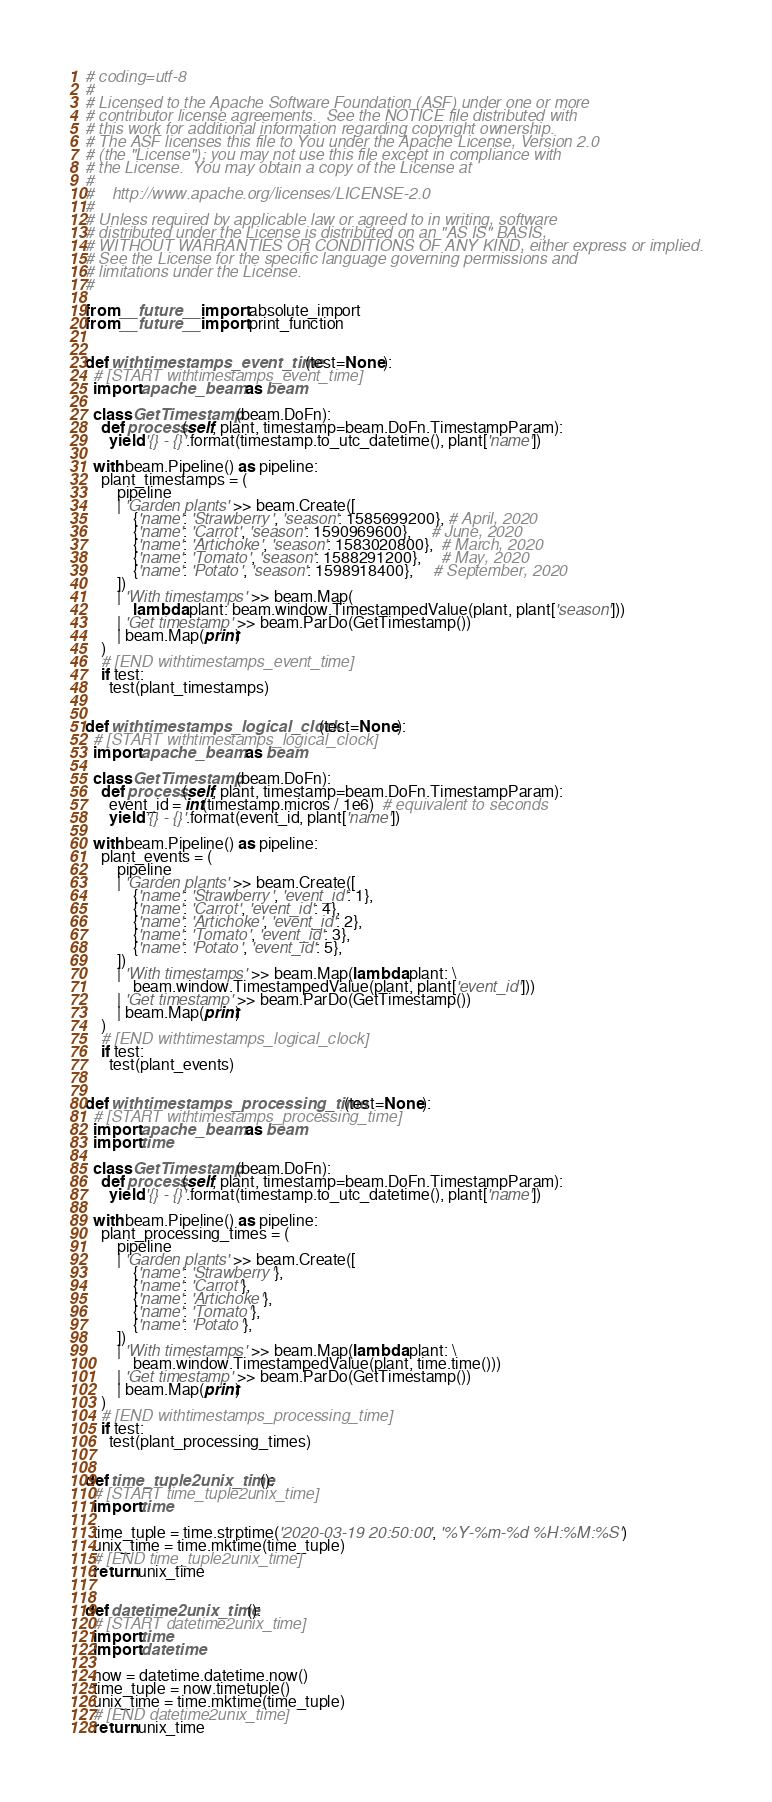Convert code to text. <code><loc_0><loc_0><loc_500><loc_500><_Python_># coding=utf-8
#
# Licensed to the Apache Software Foundation (ASF) under one or more
# contributor license agreements.  See the NOTICE file distributed with
# this work for additional information regarding copyright ownership.
# The ASF licenses this file to You under the Apache License, Version 2.0
# (the "License"); you may not use this file except in compliance with
# the License.  You may obtain a copy of the License at
#
#    http://www.apache.org/licenses/LICENSE-2.0
#
# Unless required by applicable law or agreed to in writing, software
# distributed under the License is distributed on an "AS IS" BASIS,
# WITHOUT WARRANTIES OR CONDITIONS OF ANY KIND, either express or implied.
# See the License for the specific language governing permissions and
# limitations under the License.
#

from __future__ import absolute_import
from __future__ import print_function


def withtimestamps_event_time(test=None):
  # [START withtimestamps_event_time]
  import apache_beam as beam

  class GetTimestamp(beam.DoFn):
    def process(self, plant, timestamp=beam.DoFn.TimestampParam):
      yield '{} - {}'.format(timestamp.to_utc_datetime(), plant['name'])

  with beam.Pipeline() as pipeline:
    plant_timestamps = (
        pipeline
        | 'Garden plants' >> beam.Create([
            {'name': 'Strawberry', 'season': 1585699200}, # April, 2020
            {'name': 'Carrot', 'season': 1590969600},     # June, 2020
            {'name': 'Artichoke', 'season': 1583020800},  # March, 2020
            {'name': 'Tomato', 'season': 1588291200},     # May, 2020
            {'name': 'Potato', 'season': 1598918400},     # September, 2020
        ])
        | 'With timestamps' >> beam.Map(
            lambda plant: beam.window.TimestampedValue(plant, plant['season']))
        | 'Get timestamp' >> beam.ParDo(GetTimestamp())
        | beam.Map(print)
    )
    # [END withtimestamps_event_time]
    if test:
      test(plant_timestamps)


def withtimestamps_logical_clock(test=None):
  # [START withtimestamps_logical_clock]
  import apache_beam as beam

  class GetTimestamp(beam.DoFn):
    def process(self, plant, timestamp=beam.DoFn.TimestampParam):
      event_id = int(timestamp.micros / 1e6)  # equivalent to seconds
      yield '{} - {}'.format(event_id, plant['name'])

  with beam.Pipeline() as pipeline:
    plant_events = (
        pipeline
        | 'Garden plants' >> beam.Create([
            {'name': 'Strawberry', 'event_id': 1},
            {'name': 'Carrot', 'event_id': 4},
            {'name': 'Artichoke', 'event_id': 2},
            {'name': 'Tomato', 'event_id': 3},
            {'name': 'Potato', 'event_id': 5},
        ])
        | 'With timestamps' >> beam.Map(lambda plant: \
            beam.window.TimestampedValue(plant, plant['event_id']))
        | 'Get timestamp' >> beam.ParDo(GetTimestamp())
        | beam.Map(print)
    )
    # [END withtimestamps_logical_clock]
    if test:
      test(plant_events)


def withtimestamps_processing_time(test=None):
  # [START withtimestamps_processing_time]
  import apache_beam as beam
  import time

  class GetTimestamp(beam.DoFn):
    def process(self, plant, timestamp=beam.DoFn.TimestampParam):
      yield '{} - {}'.format(timestamp.to_utc_datetime(), plant['name'])

  with beam.Pipeline() as pipeline:
    plant_processing_times = (
        pipeline
        | 'Garden plants' >> beam.Create([
            {'name': 'Strawberry'},
            {'name': 'Carrot'},
            {'name': 'Artichoke'},
            {'name': 'Tomato'},
            {'name': 'Potato'},
        ])
        | 'With timestamps' >> beam.Map(lambda plant: \
            beam.window.TimestampedValue(plant, time.time()))
        | 'Get timestamp' >> beam.ParDo(GetTimestamp())
        | beam.Map(print)
    )
    # [END withtimestamps_processing_time]
    if test:
      test(plant_processing_times)


def time_tuple2unix_time():
  # [START time_tuple2unix_time]
  import time

  time_tuple = time.strptime('2020-03-19 20:50:00', '%Y-%m-%d %H:%M:%S')
  unix_time = time.mktime(time_tuple)
  # [END time_tuple2unix_time]
  return unix_time


def datetime2unix_time():
  # [START datetime2unix_time]
  import time
  import datetime

  now = datetime.datetime.now()
  time_tuple = now.timetuple()
  unix_time = time.mktime(time_tuple)
  # [END datetime2unix_time]
  return unix_time
</code> 